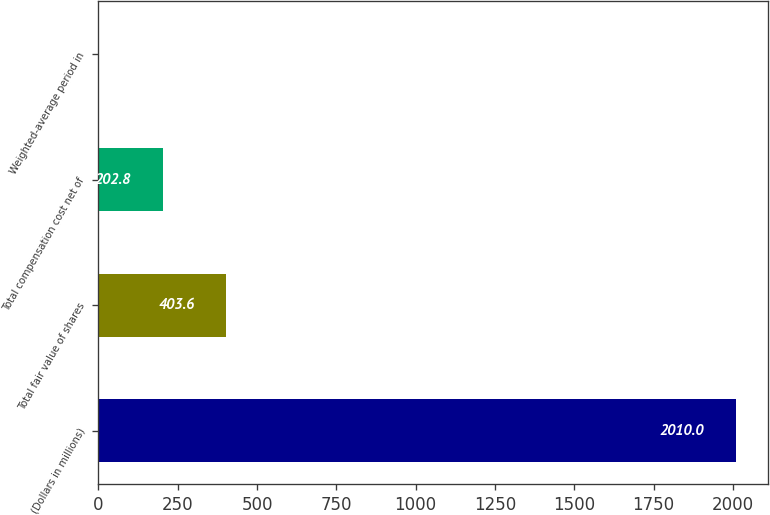Convert chart to OTSL. <chart><loc_0><loc_0><loc_500><loc_500><bar_chart><fcel>(Dollars in millions)<fcel>Total fair value of shares<fcel>Total compensation cost net of<fcel>Weighted-average period in<nl><fcel>2010<fcel>403.6<fcel>202.8<fcel>2<nl></chart> 